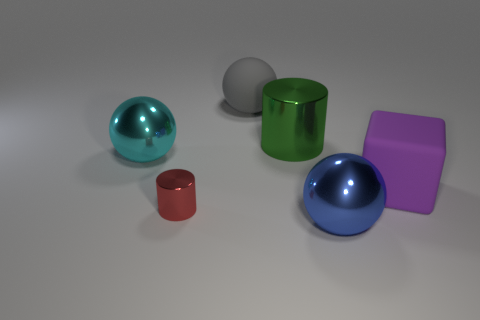How do the shadows cast by the objects inform us about the light source? The shadows are soft-edged and lie mostly to the right of the objects, indicating that the light source is positioned to the left, possibly at a mid-height angle, casting diffuse shadows that suggest an ambient light setting.  Could you infer the time of day in this setting from the lighting and shadows? Given the artificial nature of this image, it resembles a controlled studio lighting rather than natural light, making it challenging to infer any specific time of day from the lighting and shadows presented here. 